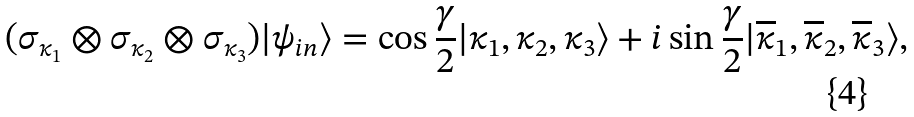<formula> <loc_0><loc_0><loc_500><loc_500>( \sigma _ { \kappa _ { 1 } } \otimes \sigma _ { \kappa _ { 2 } } \otimes \sigma _ { \kappa _ { 3 } } ) | \psi _ { i n } \rangle & = \cos \frac { \gamma } { 2 } | \kappa _ { 1 } , \kappa _ { 2 } , \kappa _ { 3 } \rangle + i \sin \frac { \gamma } { 2 } | \overline { \kappa } _ { 1 } , \overline { \kappa } _ { 2 } , \overline { \kappa } _ { 3 } \rangle ,</formula> 